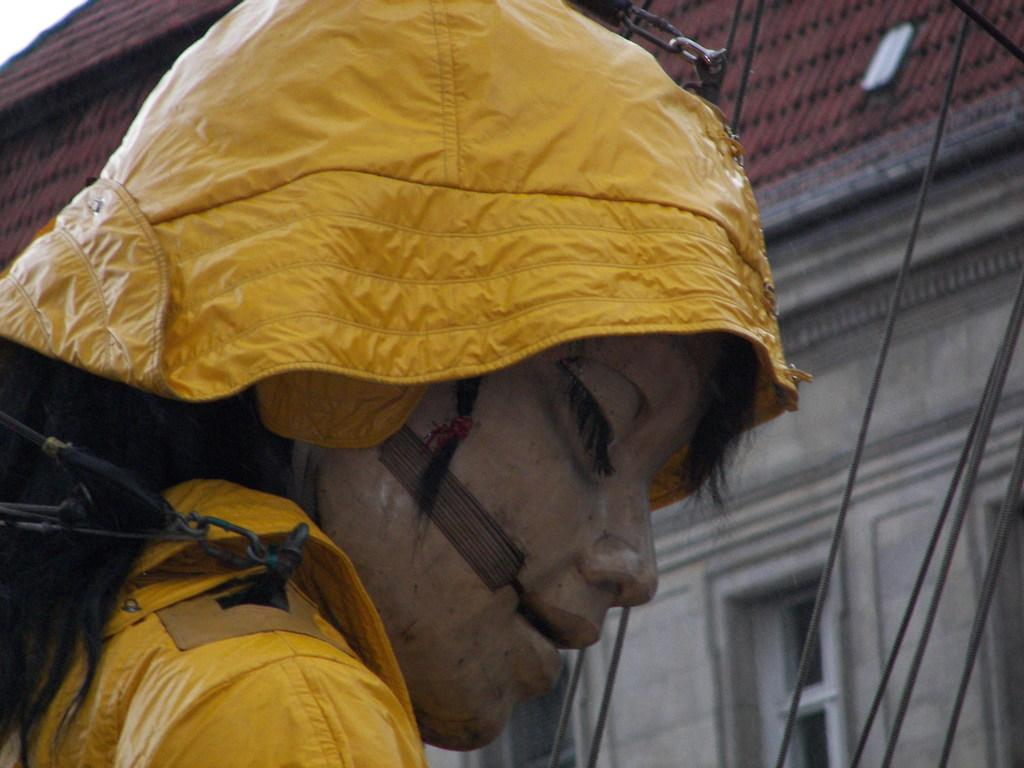What is the main subject of the image? There is a doll in the image. What is the doll wearing? The doll is wearing a yellow dress. What can be seen in the background of the image? There are wires and a building visible in the background. What colors are the building in the background? The building is cream and brown in color. What else is visible in the background of the image? The sky is visible in the background of the image. What type of design can be seen on the potato in the image? There is no potato present in the image, so it is not possible to answer that question. 